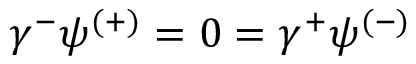<formula> <loc_0><loc_0><loc_500><loc_500>\gamma ^ { - } \psi ^ { ( + ) } = 0 = \gamma ^ { + } \psi ^ { ( - ) }</formula> 